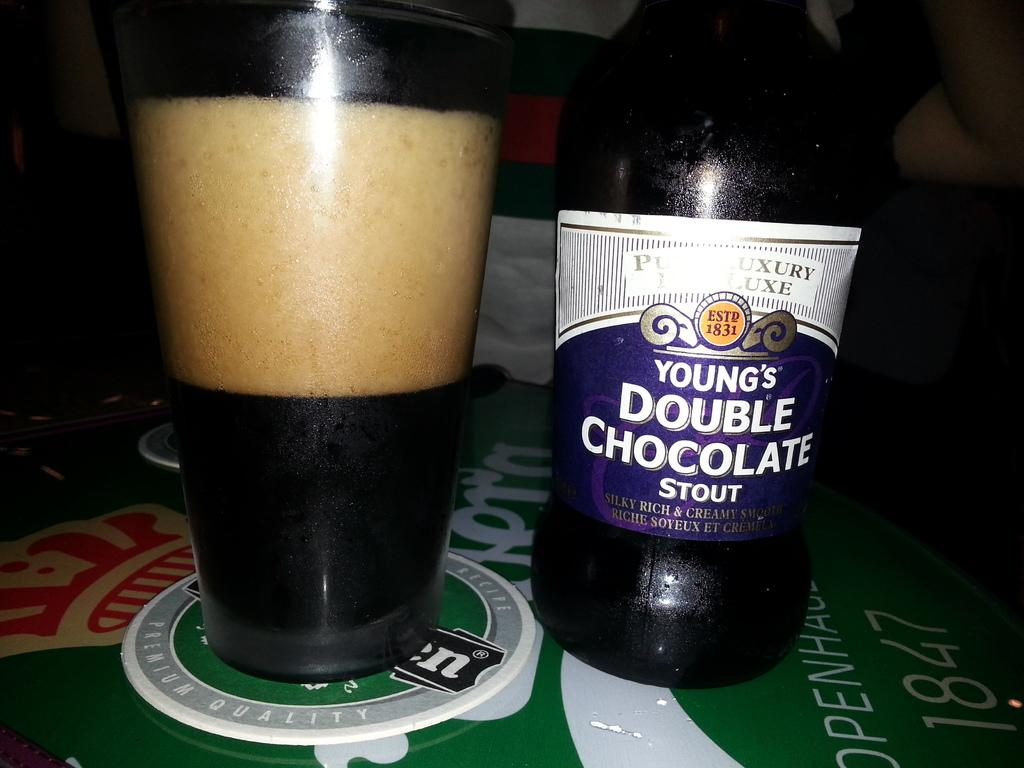<image>
Share a concise interpretation of the image provided. A bottle of double chocolate stout sits next to a glass filled with dark foamy liquid. 